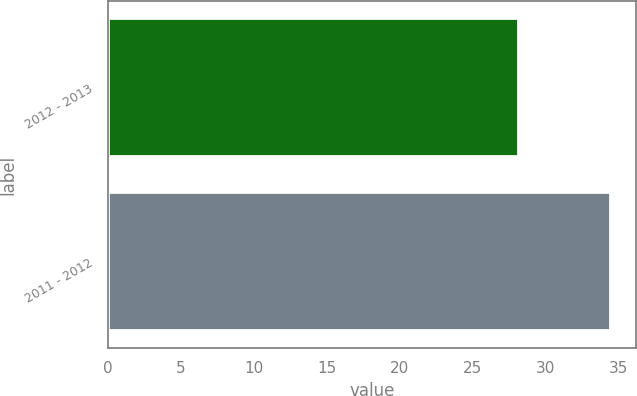Convert chart. <chart><loc_0><loc_0><loc_500><loc_500><bar_chart><fcel>2012 - 2013<fcel>2011 - 2012<nl><fcel>28.2<fcel>34.5<nl></chart> 